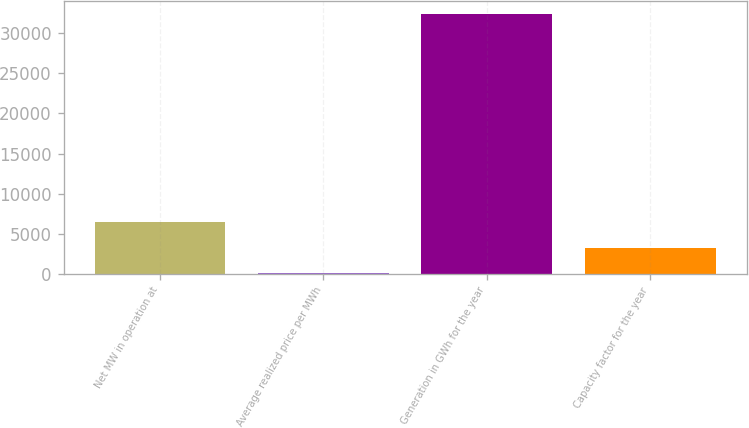Convert chart. <chart><loc_0><loc_0><loc_500><loc_500><bar_chart><fcel>Net MW in operation at<fcel>Average realized price per MWh<fcel>Generation in GWh for the year<fcel>Capacity factor for the year<nl><fcel>6507.3<fcel>39.38<fcel>32379<fcel>3273.34<nl></chart> 